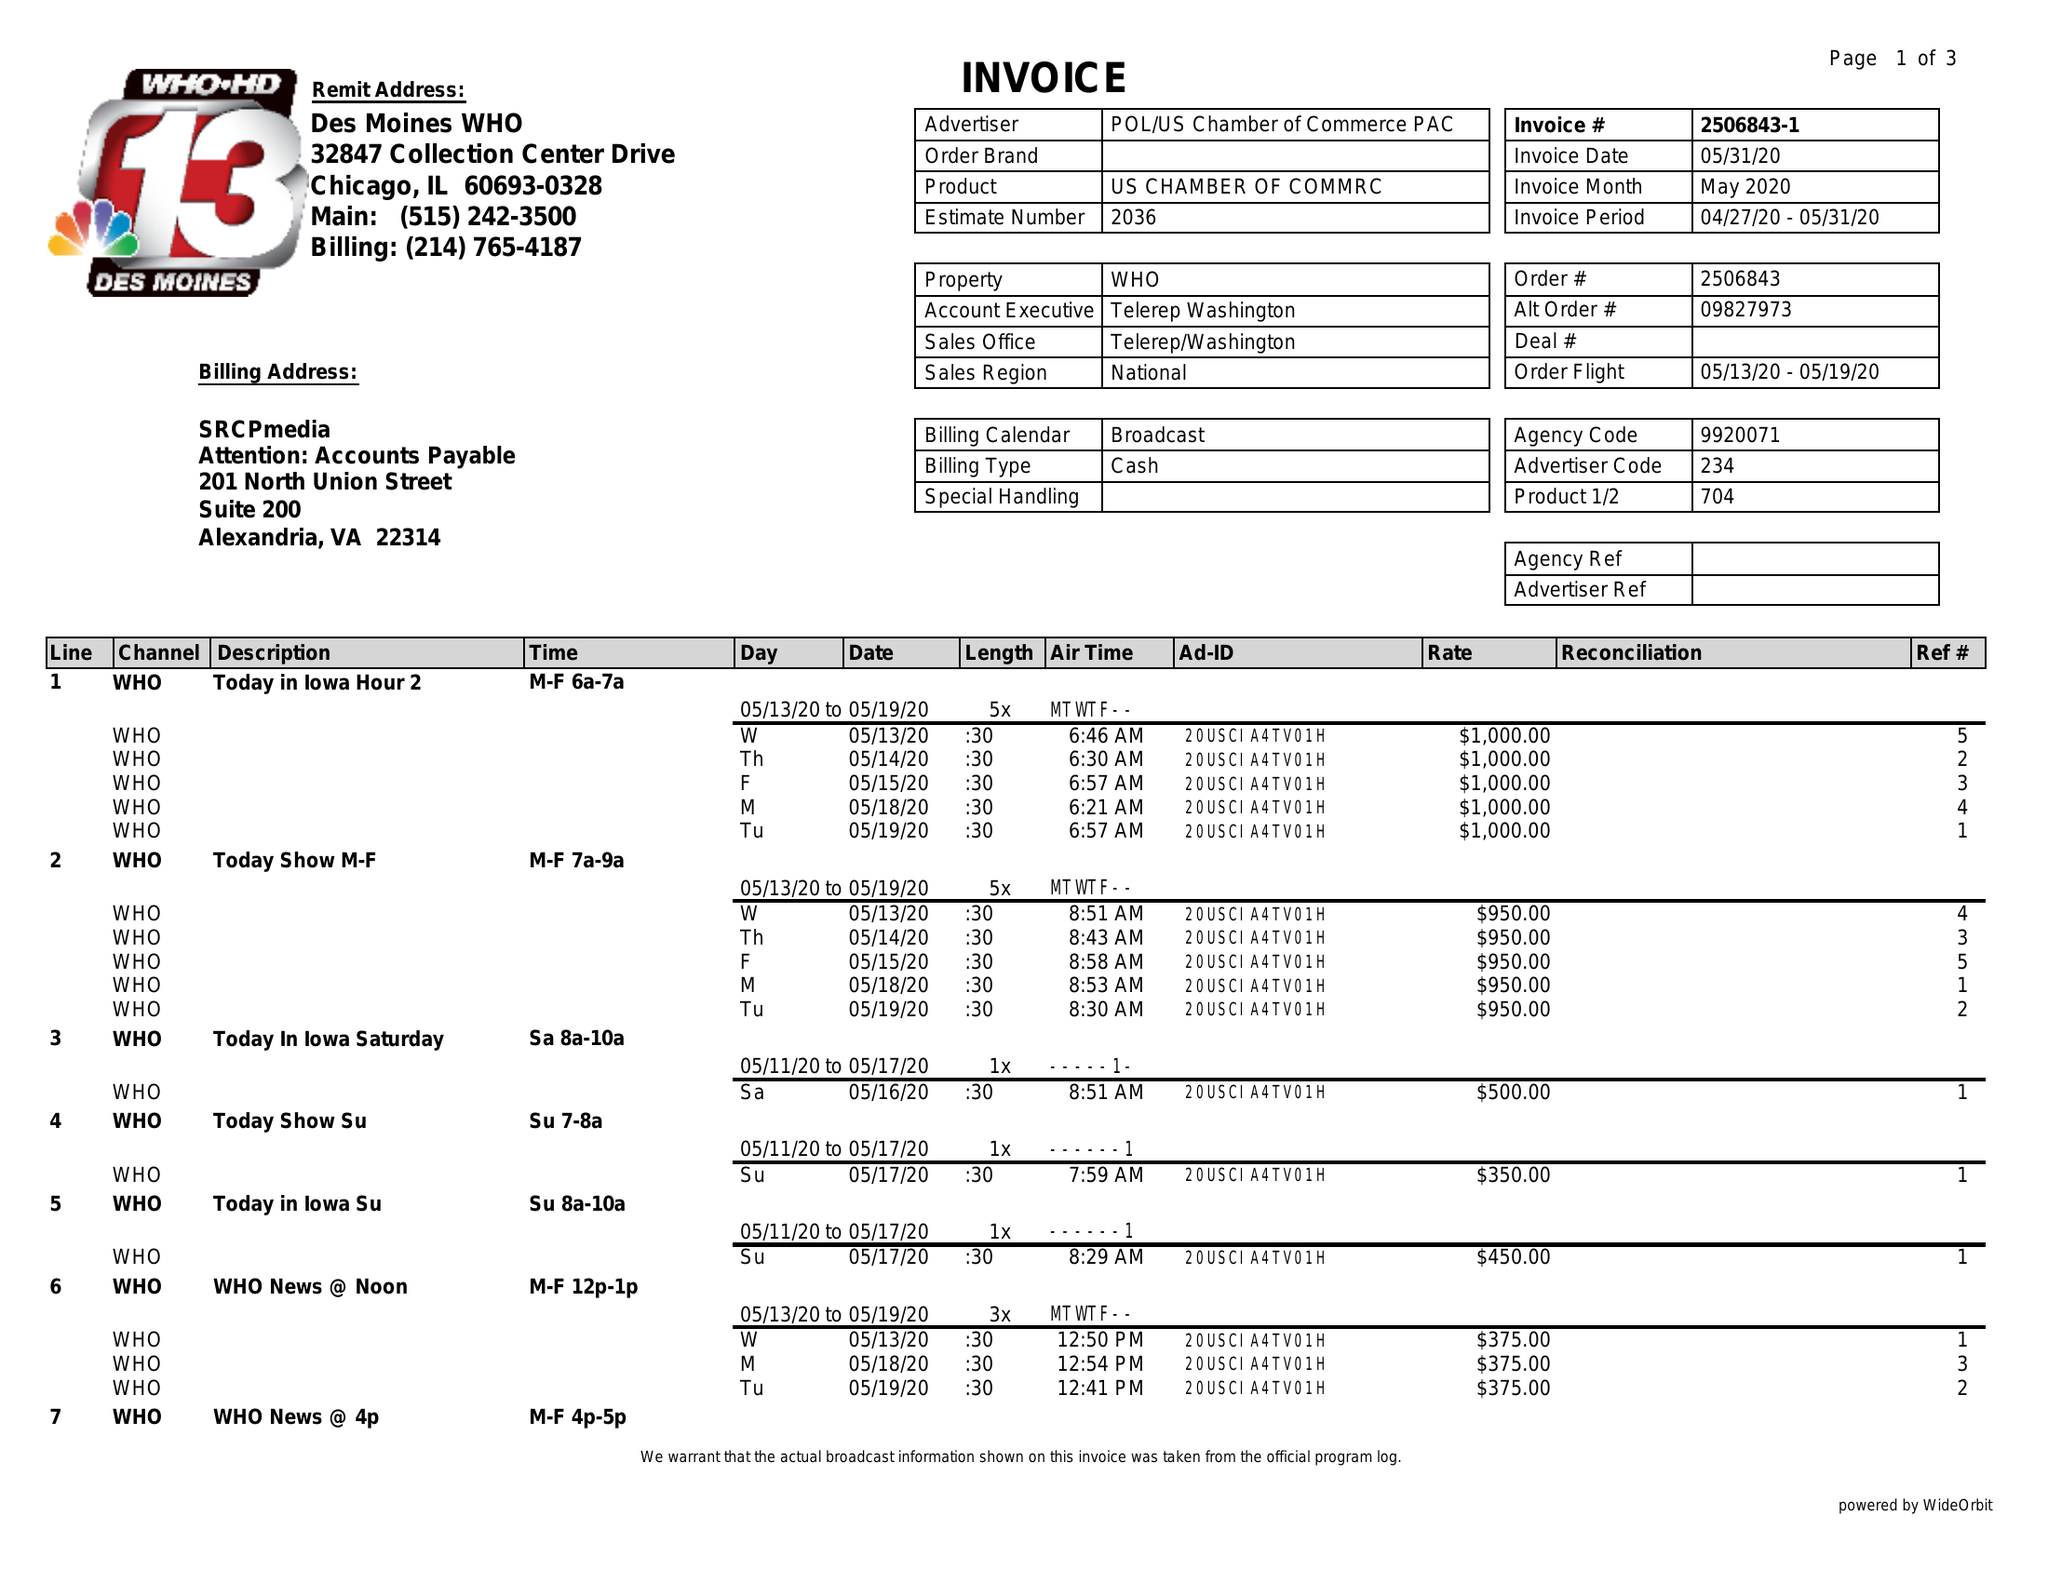What is the value for the flight_from?
Answer the question using a single word or phrase. 05/13/20 